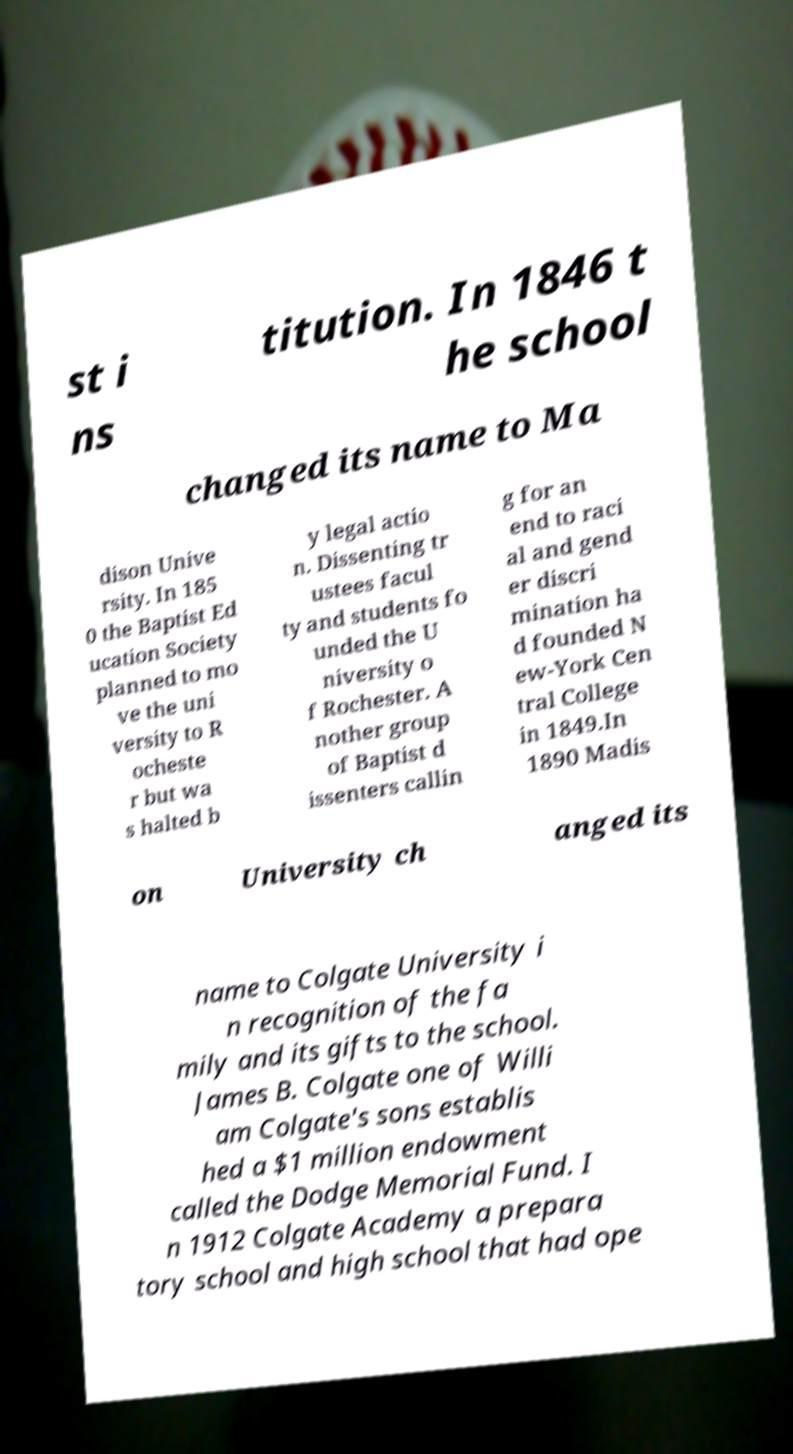What messages or text are displayed in this image? I need them in a readable, typed format. st i ns titution. In 1846 t he school changed its name to Ma dison Unive rsity. In 185 0 the Baptist Ed ucation Society planned to mo ve the uni versity to R ocheste r but wa s halted b y legal actio n. Dissenting tr ustees facul ty and students fo unded the U niversity o f Rochester. A nother group of Baptist d issenters callin g for an end to raci al and gend er discri mination ha d founded N ew-York Cen tral College in 1849.In 1890 Madis on University ch anged its name to Colgate University i n recognition of the fa mily and its gifts to the school. James B. Colgate one of Willi am Colgate's sons establis hed a $1 million endowment called the Dodge Memorial Fund. I n 1912 Colgate Academy a prepara tory school and high school that had ope 